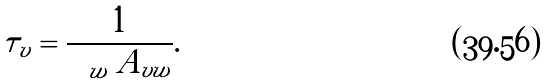Convert formula to latex. <formula><loc_0><loc_0><loc_500><loc_500>\tau _ { v } = \frac { 1 } { \sum _ { w } A _ { v w } } .</formula> 